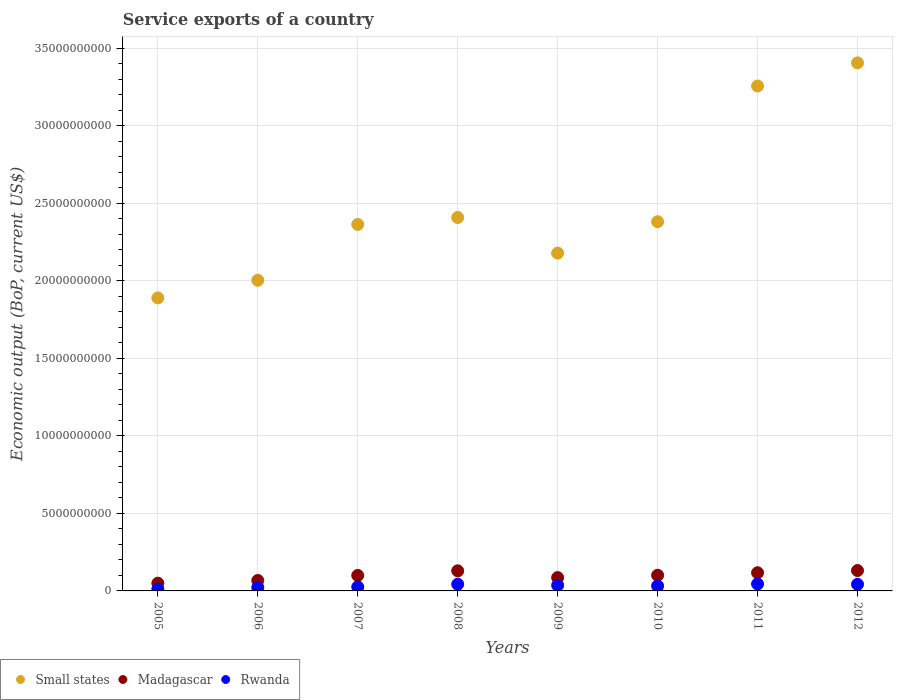What is the service exports in Madagascar in 2009?
Give a very brief answer. 8.60e+08. Across all years, what is the maximum service exports in Rwanda?
Make the answer very short. 4.49e+08. Across all years, what is the minimum service exports in Small states?
Your response must be concise. 1.89e+1. In which year was the service exports in Small states maximum?
Offer a terse response. 2012. In which year was the service exports in Rwanda minimum?
Your answer should be very brief. 2005. What is the total service exports in Madagascar in the graph?
Give a very brief answer. 7.83e+09. What is the difference between the service exports in Madagascar in 2006 and that in 2008?
Your answer should be very brief. -6.23e+08. What is the difference between the service exports in Madagascar in 2009 and the service exports in Rwanda in 2008?
Provide a short and direct response. 4.27e+08. What is the average service exports in Rwanda per year?
Make the answer very short. 3.25e+08. In the year 2011, what is the difference between the service exports in Small states and service exports in Madagascar?
Your answer should be very brief. 3.14e+1. What is the ratio of the service exports in Rwanda in 2005 to that in 2012?
Your answer should be compact. 0.28. Is the service exports in Rwanda in 2006 less than that in 2008?
Your response must be concise. Yes. Is the difference between the service exports in Small states in 2005 and 2012 greater than the difference between the service exports in Madagascar in 2005 and 2012?
Offer a terse response. No. What is the difference between the highest and the second highest service exports in Madagascar?
Offer a terse response. 1.82e+07. What is the difference between the highest and the lowest service exports in Small states?
Keep it short and to the point. 1.52e+1. Is the service exports in Small states strictly greater than the service exports in Rwanda over the years?
Your answer should be very brief. Yes. Is the service exports in Small states strictly less than the service exports in Madagascar over the years?
Give a very brief answer. No. How many dotlines are there?
Your answer should be very brief. 3. How many years are there in the graph?
Offer a very short reply. 8. What is the difference between two consecutive major ticks on the Y-axis?
Make the answer very short. 5.00e+09. Does the graph contain any zero values?
Offer a very short reply. No. Does the graph contain grids?
Keep it short and to the point. Yes. How many legend labels are there?
Offer a very short reply. 3. What is the title of the graph?
Make the answer very short. Service exports of a country. What is the label or title of the Y-axis?
Offer a very short reply. Economic output (BoP, current US$). What is the Economic output (BoP, current US$) of Small states in 2005?
Your response must be concise. 1.89e+1. What is the Economic output (BoP, current US$) of Madagascar in 2005?
Ensure brevity in your answer.  4.99e+08. What is the Economic output (BoP, current US$) in Rwanda in 2005?
Your answer should be very brief. 1.20e+08. What is the Economic output (BoP, current US$) of Small states in 2006?
Your answer should be very brief. 2.00e+1. What is the Economic output (BoP, current US$) in Madagascar in 2006?
Offer a terse response. 6.73e+08. What is the Economic output (BoP, current US$) of Rwanda in 2006?
Your answer should be very brief. 2.24e+08. What is the Economic output (BoP, current US$) of Small states in 2007?
Your response must be concise. 2.36e+1. What is the Economic output (BoP, current US$) in Madagascar in 2007?
Keep it short and to the point. 9.99e+08. What is the Economic output (BoP, current US$) of Rwanda in 2007?
Give a very brief answer. 2.62e+08. What is the Economic output (BoP, current US$) in Small states in 2008?
Provide a succinct answer. 2.41e+1. What is the Economic output (BoP, current US$) in Madagascar in 2008?
Ensure brevity in your answer.  1.30e+09. What is the Economic output (BoP, current US$) of Rwanda in 2008?
Your response must be concise. 4.33e+08. What is the Economic output (BoP, current US$) of Small states in 2009?
Give a very brief answer. 2.18e+1. What is the Economic output (BoP, current US$) of Madagascar in 2009?
Make the answer very short. 8.60e+08. What is the Economic output (BoP, current US$) of Rwanda in 2009?
Provide a succinct answer. 3.61e+08. What is the Economic output (BoP, current US$) in Small states in 2010?
Provide a succinct answer. 2.38e+1. What is the Economic output (BoP, current US$) in Madagascar in 2010?
Your answer should be compact. 1.01e+09. What is the Economic output (BoP, current US$) of Rwanda in 2010?
Provide a short and direct response. 3.25e+08. What is the Economic output (BoP, current US$) of Small states in 2011?
Offer a terse response. 3.26e+1. What is the Economic output (BoP, current US$) of Madagascar in 2011?
Keep it short and to the point. 1.17e+09. What is the Economic output (BoP, current US$) of Rwanda in 2011?
Give a very brief answer. 4.49e+08. What is the Economic output (BoP, current US$) of Small states in 2012?
Your response must be concise. 3.41e+1. What is the Economic output (BoP, current US$) in Madagascar in 2012?
Your answer should be compact. 1.31e+09. What is the Economic output (BoP, current US$) of Rwanda in 2012?
Make the answer very short. 4.25e+08. Across all years, what is the maximum Economic output (BoP, current US$) in Small states?
Give a very brief answer. 3.41e+1. Across all years, what is the maximum Economic output (BoP, current US$) of Madagascar?
Your answer should be compact. 1.31e+09. Across all years, what is the maximum Economic output (BoP, current US$) in Rwanda?
Provide a short and direct response. 4.49e+08. Across all years, what is the minimum Economic output (BoP, current US$) of Small states?
Your answer should be compact. 1.89e+1. Across all years, what is the minimum Economic output (BoP, current US$) in Madagascar?
Keep it short and to the point. 4.99e+08. Across all years, what is the minimum Economic output (BoP, current US$) in Rwanda?
Give a very brief answer. 1.20e+08. What is the total Economic output (BoP, current US$) in Small states in the graph?
Give a very brief answer. 1.99e+11. What is the total Economic output (BoP, current US$) of Madagascar in the graph?
Offer a terse response. 7.83e+09. What is the total Economic output (BoP, current US$) in Rwanda in the graph?
Ensure brevity in your answer.  2.60e+09. What is the difference between the Economic output (BoP, current US$) in Small states in 2005 and that in 2006?
Keep it short and to the point. -1.14e+09. What is the difference between the Economic output (BoP, current US$) of Madagascar in 2005 and that in 2006?
Your answer should be very brief. -1.74e+08. What is the difference between the Economic output (BoP, current US$) of Rwanda in 2005 and that in 2006?
Provide a short and direct response. -1.04e+08. What is the difference between the Economic output (BoP, current US$) of Small states in 2005 and that in 2007?
Your response must be concise. -4.74e+09. What is the difference between the Economic output (BoP, current US$) of Madagascar in 2005 and that in 2007?
Offer a very short reply. -5.00e+08. What is the difference between the Economic output (BoP, current US$) of Rwanda in 2005 and that in 2007?
Give a very brief answer. -1.42e+08. What is the difference between the Economic output (BoP, current US$) of Small states in 2005 and that in 2008?
Ensure brevity in your answer.  -5.19e+09. What is the difference between the Economic output (BoP, current US$) of Madagascar in 2005 and that in 2008?
Offer a very short reply. -7.97e+08. What is the difference between the Economic output (BoP, current US$) in Rwanda in 2005 and that in 2008?
Your answer should be compact. -3.13e+08. What is the difference between the Economic output (BoP, current US$) of Small states in 2005 and that in 2009?
Give a very brief answer. -2.89e+09. What is the difference between the Economic output (BoP, current US$) of Madagascar in 2005 and that in 2009?
Make the answer very short. -3.60e+08. What is the difference between the Economic output (BoP, current US$) in Rwanda in 2005 and that in 2009?
Keep it short and to the point. -2.42e+08. What is the difference between the Economic output (BoP, current US$) of Small states in 2005 and that in 2010?
Offer a very short reply. -4.91e+09. What is the difference between the Economic output (BoP, current US$) of Madagascar in 2005 and that in 2010?
Your answer should be compact. -5.13e+08. What is the difference between the Economic output (BoP, current US$) of Rwanda in 2005 and that in 2010?
Make the answer very short. -2.05e+08. What is the difference between the Economic output (BoP, current US$) of Small states in 2005 and that in 2011?
Ensure brevity in your answer.  -1.37e+1. What is the difference between the Economic output (BoP, current US$) of Madagascar in 2005 and that in 2011?
Offer a very short reply. -6.74e+08. What is the difference between the Economic output (BoP, current US$) in Rwanda in 2005 and that in 2011?
Provide a succinct answer. -3.29e+08. What is the difference between the Economic output (BoP, current US$) in Small states in 2005 and that in 2012?
Offer a terse response. -1.52e+1. What is the difference between the Economic output (BoP, current US$) of Madagascar in 2005 and that in 2012?
Give a very brief answer. -8.15e+08. What is the difference between the Economic output (BoP, current US$) of Rwanda in 2005 and that in 2012?
Keep it short and to the point. -3.06e+08. What is the difference between the Economic output (BoP, current US$) of Small states in 2006 and that in 2007?
Offer a terse response. -3.60e+09. What is the difference between the Economic output (BoP, current US$) of Madagascar in 2006 and that in 2007?
Ensure brevity in your answer.  -3.26e+08. What is the difference between the Economic output (BoP, current US$) in Rwanda in 2006 and that in 2007?
Your response must be concise. -3.82e+07. What is the difference between the Economic output (BoP, current US$) in Small states in 2006 and that in 2008?
Provide a short and direct response. -4.05e+09. What is the difference between the Economic output (BoP, current US$) in Madagascar in 2006 and that in 2008?
Provide a succinct answer. -6.23e+08. What is the difference between the Economic output (BoP, current US$) of Rwanda in 2006 and that in 2008?
Offer a very short reply. -2.09e+08. What is the difference between the Economic output (BoP, current US$) of Small states in 2006 and that in 2009?
Your response must be concise. -1.75e+09. What is the difference between the Economic output (BoP, current US$) in Madagascar in 2006 and that in 2009?
Ensure brevity in your answer.  -1.87e+08. What is the difference between the Economic output (BoP, current US$) of Rwanda in 2006 and that in 2009?
Make the answer very short. -1.38e+08. What is the difference between the Economic output (BoP, current US$) of Small states in 2006 and that in 2010?
Your response must be concise. -3.78e+09. What is the difference between the Economic output (BoP, current US$) of Madagascar in 2006 and that in 2010?
Offer a terse response. -3.39e+08. What is the difference between the Economic output (BoP, current US$) in Rwanda in 2006 and that in 2010?
Give a very brief answer. -1.02e+08. What is the difference between the Economic output (BoP, current US$) in Small states in 2006 and that in 2011?
Ensure brevity in your answer.  -1.25e+1. What is the difference between the Economic output (BoP, current US$) in Madagascar in 2006 and that in 2011?
Your response must be concise. -5.00e+08. What is the difference between the Economic output (BoP, current US$) of Rwanda in 2006 and that in 2011?
Your response must be concise. -2.25e+08. What is the difference between the Economic output (BoP, current US$) in Small states in 2006 and that in 2012?
Keep it short and to the point. -1.40e+1. What is the difference between the Economic output (BoP, current US$) in Madagascar in 2006 and that in 2012?
Provide a short and direct response. -6.42e+08. What is the difference between the Economic output (BoP, current US$) of Rwanda in 2006 and that in 2012?
Your answer should be compact. -2.02e+08. What is the difference between the Economic output (BoP, current US$) in Small states in 2007 and that in 2008?
Provide a short and direct response. -4.49e+08. What is the difference between the Economic output (BoP, current US$) in Madagascar in 2007 and that in 2008?
Your response must be concise. -2.97e+08. What is the difference between the Economic output (BoP, current US$) in Rwanda in 2007 and that in 2008?
Offer a terse response. -1.71e+08. What is the difference between the Economic output (BoP, current US$) in Small states in 2007 and that in 2009?
Offer a terse response. 1.85e+09. What is the difference between the Economic output (BoP, current US$) of Madagascar in 2007 and that in 2009?
Ensure brevity in your answer.  1.40e+08. What is the difference between the Economic output (BoP, current US$) of Rwanda in 2007 and that in 2009?
Ensure brevity in your answer.  -9.95e+07. What is the difference between the Economic output (BoP, current US$) in Small states in 2007 and that in 2010?
Offer a very short reply. -1.75e+08. What is the difference between the Economic output (BoP, current US$) in Madagascar in 2007 and that in 2010?
Your answer should be compact. -1.25e+07. What is the difference between the Economic output (BoP, current US$) in Rwanda in 2007 and that in 2010?
Keep it short and to the point. -6.33e+07. What is the difference between the Economic output (BoP, current US$) in Small states in 2007 and that in 2011?
Keep it short and to the point. -8.93e+09. What is the difference between the Economic output (BoP, current US$) in Madagascar in 2007 and that in 2011?
Keep it short and to the point. -1.74e+08. What is the difference between the Economic output (BoP, current US$) of Rwanda in 2007 and that in 2011?
Make the answer very short. -1.87e+08. What is the difference between the Economic output (BoP, current US$) of Small states in 2007 and that in 2012?
Give a very brief answer. -1.04e+1. What is the difference between the Economic output (BoP, current US$) of Madagascar in 2007 and that in 2012?
Your response must be concise. -3.15e+08. What is the difference between the Economic output (BoP, current US$) of Rwanda in 2007 and that in 2012?
Provide a short and direct response. -1.63e+08. What is the difference between the Economic output (BoP, current US$) in Small states in 2008 and that in 2009?
Your answer should be compact. 2.30e+09. What is the difference between the Economic output (BoP, current US$) in Madagascar in 2008 and that in 2009?
Give a very brief answer. 4.37e+08. What is the difference between the Economic output (BoP, current US$) of Rwanda in 2008 and that in 2009?
Your response must be concise. 7.11e+07. What is the difference between the Economic output (BoP, current US$) of Small states in 2008 and that in 2010?
Offer a very short reply. 2.74e+08. What is the difference between the Economic output (BoP, current US$) in Madagascar in 2008 and that in 2010?
Offer a very short reply. 2.85e+08. What is the difference between the Economic output (BoP, current US$) of Rwanda in 2008 and that in 2010?
Your answer should be very brief. 1.07e+08. What is the difference between the Economic output (BoP, current US$) of Small states in 2008 and that in 2011?
Offer a terse response. -8.48e+09. What is the difference between the Economic output (BoP, current US$) of Madagascar in 2008 and that in 2011?
Your response must be concise. 1.23e+08. What is the difference between the Economic output (BoP, current US$) of Rwanda in 2008 and that in 2011?
Your answer should be compact. -1.59e+07. What is the difference between the Economic output (BoP, current US$) of Small states in 2008 and that in 2012?
Provide a short and direct response. -9.97e+09. What is the difference between the Economic output (BoP, current US$) in Madagascar in 2008 and that in 2012?
Keep it short and to the point. -1.82e+07. What is the difference between the Economic output (BoP, current US$) of Rwanda in 2008 and that in 2012?
Offer a terse response. 7.26e+06. What is the difference between the Economic output (BoP, current US$) of Small states in 2009 and that in 2010?
Offer a terse response. -2.02e+09. What is the difference between the Economic output (BoP, current US$) in Madagascar in 2009 and that in 2010?
Offer a terse response. -1.52e+08. What is the difference between the Economic output (BoP, current US$) in Rwanda in 2009 and that in 2010?
Ensure brevity in your answer.  3.62e+07. What is the difference between the Economic output (BoP, current US$) in Small states in 2009 and that in 2011?
Keep it short and to the point. -1.08e+1. What is the difference between the Economic output (BoP, current US$) of Madagascar in 2009 and that in 2011?
Your response must be concise. -3.13e+08. What is the difference between the Economic output (BoP, current US$) of Rwanda in 2009 and that in 2011?
Your response must be concise. -8.71e+07. What is the difference between the Economic output (BoP, current US$) in Small states in 2009 and that in 2012?
Keep it short and to the point. -1.23e+1. What is the difference between the Economic output (BoP, current US$) of Madagascar in 2009 and that in 2012?
Your answer should be compact. -4.55e+08. What is the difference between the Economic output (BoP, current US$) of Rwanda in 2009 and that in 2012?
Your response must be concise. -6.39e+07. What is the difference between the Economic output (BoP, current US$) in Small states in 2010 and that in 2011?
Your answer should be compact. -8.76e+09. What is the difference between the Economic output (BoP, current US$) in Madagascar in 2010 and that in 2011?
Make the answer very short. -1.61e+08. What is the difference between the Economic output (BoP, current US$) in Rwanda in 2010 and that in 2011?
Offer a very short reply. -1.23e+08. What is the difference between the Economic output (BoP, current US$) in Small states in 2010 and that in 2012?
Keep it short and to the point. -1.02e+1. What is the difference between the Economic output (BoP, current US$) in Madagascar in 2010 and that in 2012?
Your response must be concise. -3.03e+08. What is the difference between the Economic output (BoP, current US$) in Rwanda in 2010 and that in 2012?
Provide a succinct answer. -1.00e+08. What is the difference between the Economic output (BoP, current US$) of Small states in 2011 and that in 2012?
Keep it short and to the point. -1.49e+09. What is the difference between the Economic output (BoP, current US$) in Madagascar in 2011 and that in 2012?
Offer a very short reply. -1.41e+08. What is the difference between the Economic output (BoP, current US$) in Rwanda in 2011 and that in 2012?
Offer a very short reply. 2.32e+07. What is the difference between the Economic output (BoP, current US$) in Small states in 2005 and the Economic output (BoP, current US$) in Madagascar in 2006?
Make the answer very short. 1.82e+1. What is the difference between the Economic output (BoP, current US$) in Small states in 2005 and the Economic output (BoP, current US$) in Rwanda in 2006?
Your answer should be compact. 1.87e+1. What is the difference between the Economic output (BoP, current US$) in Madagascar in 2005 and the Economic output (BoP, current US$) in Rwanda in 2006?
Offer a very short reply. 2.76e+08. What is the difference between the Economic output (BoP, current US$) of Small states in 2005 and the Economic output (BoP, current US$) of Madagascar in 2007?
Your answer should be very brief. 1.79e+1. What is the difference between the Economic output (BoP, current US$) in Small states in 2005 and the Economic output (BoP, current US$) in Rwanda in 2007?
Provide a short and direct response. 1.86e+1. What is the difference between the Economic output (BoP, current US$) in Madagascar in 2005 and the Economic output (BoP, current US$) in Rwanda in 2007?
Make the answer very short. 2.37e+08. What is the difference between the Economic output (BoP, current US$) in Small states in 2005 and the Economic output (BoP, current US$) in Madagascar in 2008?
Provide a succinct answer. 1.76e+1. What is the difference between the Economic output (BoP, current US$) of Small states in 2005 and the Economic output (BoP, current US$) of Rwanda in 2008?
Your answer should be compact. 1.85e+1. What is the difference between the Economic output (BoP, current US$) of Madagascar in 2005 and the Economic output (BoP, current US$) of Rwanda in 2008?
Your answer should be very brief. 6.67e+07. What is the difference between the Economic output (BoP, current US$) of Small states in 2005 and the Economic output (BoP, current US$) of Madagascar in 2009?
Keep it short and to the point. 1.80e+1. What is the difference between the Economic output (BoP, current US$) of Small states in 2005 and the Economic output (BoP, current US$) of Rwanda in 2009?
Provide a short and direct response. 1.85e+1. What is the difference between the Economic output (BoP, current US$) of Madagascar in 2005 and the Economic output (BoP, current US$) of Rwanda in 2009?
Give a very brief answer. 1.38e+08. What is the difference between the Economic output (BoP, current US$) in Small states in 2005 and the Economic output (BoP, current US$) in Madagascar in 2010?
Provide a short and direct response. 1.79e+1. What is the difference between the Economic output (BoP, current US$) of Small states in 2005 and the Economic output (BoP, current US$) of Rwanda in 2010?
Your answer should be very brief. 1.86e+1. What is the difference between the Economic output (BoP, current US$) in Madagascar in 2005 and the Economic output (BoP, current US$) in Rwanda in 2010?
Keep it short and to the point. 1.74e+08. What is the difference between the Economic output (BoP, current US$) in Small states in 2005 and the Economic output (BoP, current US$) in Madagascar in 2011?
Keep it short and to the point. 1.77e+1. What is the difference between the Economic output (BoP, current US$) of Small states in 2005 and the Economic output (BoP, current US$) of Rwanda in 2011?
Your answer should be very brief. 1.85e+1. What is the difference between the Economic output (BoP, current US$) of Madagascar in 2005 and the Economic output (BoP, current US$) of Rwanda in 2011?
Make the answer very short. 5.07e+07. What is the difference between the Economic output (BoP, current US$) of Small states in 2005 and the Economic output (BoP, current US$) of Madagascar in 2012?
Your answer should be very brief. 1.76e+1. What is the difference between the Economic output (BoP, current US$) in Small states in 2005 and the Economic output (BoP, current US$) in Rwanda in 2012?
Provide a succinct answer. 1.85e+1. What is the difference between the Economic output (BoP, current US$) of Madagascar in 2005 and the Economic output (BoP, current US$) of Rwanda in 2012?
Your answer should be compact. 7.39e+07. What is the difference between the Economic output (BoP, current US$) of Small states in 2006 and the Economic output (BoP, current US$) of Madagascar in 2007?
Ensure brevity in your answer.  1.90e+1. What is the difference between the Economic output (BoP, current US$) of Small states in 2006 and the Economic output (BoP, current US$) of Rwanda in 2007?
Provide a short and direct response. 1.98e+1. What is the difference between the Economic output (BoP, current US$) in Madagascar in 2006 and the Economic output (BoP, current US$) in Rwanda in 2007?
Give a very brief answer. 4.11e+08. What is the difference between the Economic output (BoP, current US$) of Small states in 2006 and the Economic output (BoP, current US$) of Madagascar in 2008?
Offer a terse response. 1.87e+1. What is the difference between the Economic output (BoP, current US$) of Small states in 2006 and the Economic output (BoP, current US$) of Rwanda in 2008?
Make the answer very short. 1.96e+1. What is the difference between the Economic output (BoP, current US$) of Madagascar in 2006 and the Economic output (BoP, current US$) of Rwanda in 2008?
Give a very brief answer. 2.40e+08. What is the difference between the Economic output (BoP, current US$) of Small states in 2006 and the Economic output (BoP, current US$) of Madagascar in 2009?
Make the answer very short. 1.92e+1. What is the difference between the Economic output (BoP, current US$) in Small states in 2006 and the Economic output (BoP, current US$) in Rwanda in 2009?
Your answer should be very brief. 1.97e+1. What is the difference between the Economic output (BoP, current US$) of Madagascar in 2006 and the Economic output (BoP, current US$) of Rwanda in 2009?
Ensure brevity in your answer.  3.11e+08. What is the difference between the Economic output (BoP, current US$) of Small states in 2006 and the Economic output (BoP, current US$) of Madagascar in 2010?
Provide a succinct answer. 1.90e+1. What is the difference between the Economic output (BoP, current US$) of Small states in 2006 and the Economic output (BoP, current US$) of Rwanda in 2010?
Ensure brevity in your answer.  1.97e+1. What is the difference between the Economic output (BoP, current US$) of Madagascar in 2006 and the Economic output (BoP, current US$) of Rwanda in 2010?
Your answer should be compact. 3.48e+08. What is the difference between the Economic output (BoP, current US$) in Small states in 2006 and the Economic output (BoP, current US$) in Madagascar in 2011?
Give a very brief answer. 1.89e+1. What is the difference between the Economic output (BoP, current US$) in Small states in 2006 and the Economic output (BoP, current US$) in Rwanda in 2011?
Your answer should be compact. 1.96e+1. What is the difference between the Economic output (BoP, current US$) of Madagascar in 2006 and the Economic output (BoP, current US$) of Rwanda in 2011?
Keep it short and to the point. 2.24e+08. What is the difference between the Economic output (BoP, current US$) of Small states in 2006 and the Economic output (BoP, current US$) of Madagascar in 2012?
Make the answer very short. 1.87e+1. What is the difference between the Economic output (BoP, current US$) of Small states in 2006 and the Economic output (BoP, current US$) of Rwanda in 2012?
Provide a succinct answer. 1.96e+1. What is the difference between the Economic output (BoP, current US$) of Madagascar in 2006 and the Economic output (BoP, current US$) of Rwanda in 2012?
Your response must be concise. 2.48e+08. What is the difference between the Economic output (BoP, current US$) of Small states in 2007 and the Economic output (BoP, current US$) of Madagascar in 2008?
Your response must be concise. 2.23e+1. What is the difference between the Economic output (BoP, current US$) in Small states in 2007 and the Economic output (BoP, current US$) in Rwanda in 2008?
Make the answer very short. 2.32e+1. What is the difference between the Economic output (BoP, current US$) of Madagascar in 2007 and the Economic output (BoP, current US$) of Rwanda in 2008?
Give a very brief answer. 5.67e+08. What is the difference between the Economic output (BoP, current US$) in Small states in 2007 and the Economic output (BoP, current US$) in Madagascar in 2009?
Keep it short and to the point. 2.28e+1. What is the difference between the Economic output (BoP, current US$) in Small states in 2007 and the Economic output (BoP, current US$) in Rwanda in 2009?
Your answer should be compact. 2.33e+1. What is the difference between the Economic output (BoP, current US$) in Madagascar in 2007 and the Economic output (BoP, current US$) in Rwanda in 2009?
Provide a succinct answer. 6.38e+08. What is the difference between the Economic output (BoP, current US$) of Small states in 2007 and the Economic output (BoP, current US$) of Madagascar in 2010?
Your answer should be very brief. 2.26e+1. What is the difference between the Economic output (BoP, current US$) in Small states in 2007 and the Economic output (BoP, current US$) in Rwanda in 2010?
Give a very brief answer. 2.33e+1. What is the difference between the Economic output (BoP, current US$) in Madagascar in 2007 and the Economic output (BoP, current US$) in Rwanda in 2010?
Your answer should be very brief. 6.74e+08. What is the difference between the Economic output (BoP, current US$) of Small states in 2007 and the Economic output (BoP, current US$) of Madagascar in 2011?
Give a very brief answer. 2.25e+1. What is the difference between the Economic output (BoP, current US$) of Small states in 2007 and the Economic output (BoP, current US$) of Rwanda in 2011?
Your response must be concise. 2.32e+1. What is the difference between the Economic output (BoP, current US$) of Madagascar in 2007 and the Economic output (BoP, current US$) of Rwanda in 2011?
Offer a very short reply. 5.51e+08. What is the difference between the Economic output (BoP, current US$) of Small states in 2007 and the Economic output (BoP, current US$) of Madagascar in 2012?
Keep it short and to the point. 2.23e+1. What is the difference between the Economic output (BoP, current US$) of Small states in 2007 and the Economic output (BoP, current US$) of Rwanda in 2012?
Keep it short and to the point. 2.32e+1. What is the difference between the Economic output (BoP, current US$) in Madagascar in 2007 and the Economic output (BoP, current US$) in Rwanda in 2012?
Make the answer very short. 5.74e+08. What is the difference between the Economic output (BoP, current US$) in Small states in 2008 and the Economic output (BoP, current US$) in Madagascar in 2009?
Provide a succinct answer. 2.32e+1. What is the difference between the Economic output (BoP, current US$) in Small states in 2008 and the Economic output (BoP, current US$) in Rwanda in 2009?
Give a very brief answer. 2.37e+1. What is the difference between the Economic output (BoP, current US$) in Madagascar in 2008 and the Economic output (BoP, current US$) in Rwanda in 2009?
Your answer should be very brief. 9.35e+08. What is the difference between the Economic output (BoP, current US$) of Small states in 2008 and the Economic output (BoP, current US$) of Madagascar in 2010?
Your answer should be compact. 2.31e+1. What is the difference between the Economic output (BoP, current US$) of Small states in 2008 and the Economic output (BoP, current US$) of Rwanda in 2010?
Ensure brevity in your answer.  2.38e+1. What is the difference between the Economic output (BoP, current US$) of Madagascar in 2008 and the Economic output (BoP, current US$) of Rwanda in 2010?
Make the answer very short. 9.71e+08. What is the difference between the Economic output (BoP, current US$) of Small states in 2008 and the Economic output (BoP, current US$) of Madagascar in 2011?
Your answer should be compact. 2.29e+1. What is the difference between the Economic output (BoP, current US$) in Small states in 2008 and the Economic output (BoP, current US$) in Rwanda in 2011?
Offer a very short reply. 2.36e+1. What is the difference between the Economic output (BoP, current US$) of Madagascar in 2008 and the Economic output (BoP, current US$) of Rwanda in 2011?
Your response must be concise. 8.48e+08. What is the difference between the Economic output (BoP, current US$) of Small states in 2008 and the Economic output (BoP, current US$) of Madagascar in 2012?
Give a very brief answer. 2.28e+1. What is the difference between the Economic output (BoP, current US$) of Small states in 2008 and the Economic output (BoP, current US$) of Rwanda in 2012?
Offer a terse response. 2.37e+1. What is the difference between the Economic output (BoP, current US$) of Madagascar in 2008 and the Economic output (BoP, current US$) of Rwanda in 2012?
Your response must be concise. 8.71e+08. What is the difference between the Economic output (BoP, current US$) in Small states in 2009 and the Economic output (BoP, current US$) in Madagascar in 2010?
Your answer should be very brief. 2.08e+1. What is the difference between the Economic output (BoP, current US$) in Small states in 2009 and the Economic output (BoP, current US$) in Rwanda in 2010?
Your answer should be very brief. 2.15e+1. What is the difference between the Economic output (BoP, current US$) of Madagascar in 2009 and the Economic output (BoP, current US$) of Rwanda in 2010?
Make the answer very short. 5.34e+08. What is the difference between the Economic output (BoP, current US$) of Small states in 2009 and the Economic output (BoP, current US$) of Madagascar in 2011?
Offer a terse response. 2.06e+1. What is the difference between the Economic output (BoP, current US$) of Small states in 2009 and the Economic output (BoP, current US$) of Rwanda in 2011?
Provide a succinct answer. 2.13e+1. What is the difference between the Economic output (BoP, current US$) in Madagascar in 2009 and the Economic output (BoP, current US$) in Rwanda in 2011?
Ensure brevity in your answer.  4.11e+08. What is the difference between the Economic output (BoP, current US$) in Small states in 2009 and the Economic output (BoP, current US$) in Madagascar in 2012?
Give a very brief answer. 2.05e+1. What is the difference between the Economic output (BoP, current US$) in Small states in 2009 and the Economic output (BoP, current US$) in Rwanda in 2012?
Keep it short and to the point. 2.14e+1. What is the difference between the Economic output (BoP, current US$) in Madagascar in 2009 and the Economic output (BoP, current US$) in Rwanda in 2012?
Provide a short and direct response. 4.34e+08. What is the difference between the Economic output (BoP, current US$) in Small states in 2010 and the Economic output (BoP, current US$) in Madagascar in 2011?
Offer a very short reply. 2.26e+1. What is the difference between the Economic output (BoP, current US$) in Small states in 2010 and the Economic output (BoP, current US$) in Rwanda in 2011?
Your response must be concise. 2.34e+1. What is the difference between the Economic output (BoP, current US$) in Madagascar in 2010 and the Economic output (BoP, current US$) in Rwanda in 2011?
Your answer should be compact. 5.63e+08. What is the difference between the Economic output (BoP, current US$) in Small states in 2010 and the Economic output (BoP, current US$) in Madagascar in 2012?
Ensure brevity in your answer.  2.25e+1. What is the difference between the Economic output (BoP, current US$) of Small states in 2010 and the Economic output (BoP, current US$) of Rwanda in 2012?
Make the answer very short. 2.34e+1. What is the difference between the Economic output (BoP, current US$) of Madagascar in 2010 and the Economic output (BoP, current US$) of Rwanda in 2012?
Give a very brief answer. 5.86e+08. What is the difference between the Economic output (BoP, current US$) of Small states in 2011 and the Economic output (BoP, current US$) of Madagascar in 2012?
Offer a very short reply. 3.13e+1. What is the difference between the Economic output (BoP, current US$) in Small states in 2011 and the Economic output (BoP, current US$) in Rwanda in 2012?
Give a very brief answer. 3.21e+1. What is the difference between the Economic output (BoP, current US$) in Madagascar in 2011 and the Economic output (BoP, current US$) in Rwanda in 2012?
Offer a terse response. 7.48e+08. What is the average Economic output (BoP, current US$) of Small states per year?
Provide a succinct answer. 2.49e+1. What is the average Economic output (BoP, current US$) in Madagascar per year?
Provide a succinct answer. 9.78e+08. What is the average Economic output (BoP, current US$) in Rwanda per year?
Give a very brief answer. 3.25e+08. In the year 2005, what is the difference between the Economic output (BoP, current US$) of Small states and Economic output (BoP, current US$) of Madagascar?
Your answer should be very brief. 1.84e+1. In the year 2005, what is the difference between the Economic output (BoP, current US$) in Small states and Economic output (BoP, current US$) in Rwanda?
Offer a very short reply. 1.88e+1. In the year 2005, what is the difference between the Economic output (BoP, current US$) of Madagascar and Economic output (BoP, current US$) of Rwanda?
Your answer should be very brief. 3.79e+08. In the year 2006, what is the difference between the Economic output (BoP, current US$) in Small states and Economic output (BoP, current US$) in Madagascar?
Your answer should be compact. 1.94e+1. In the year 2006, what is the difference between the Economic output (BoP, current US$) of Small states and Economic output (BoP, current US$) of Rwanda?
Your response must be concise. 1.98e+1. In the year 2006, what is the difference between the Economic output (BoP, current US$) of Madagascar and Economic output (BoP, current US$) of Rwanda?
Ensure brevity in your answer.  4.49e+08. In the year 2007, what is the difference between the Economic output (BoP, current US$) of Small states and Economic output (BoP, current US$) of Madagascar?
Your answer should be very brief. 2.26e+1. In the year 2007, what is the difference between the Economic output (BoP, current US$) in Small states and Economic output (BoP, current US$) in Rwanda?
Ensure brevity in your answer.  2.34e+1. In the year 2007, what is the difference between the Economic output (BoP, current US$) of Madagascar and Economic output (BoP, current US$) of Rwanda?
Provide a short and direct response. 7.37e+08. In the year 2008, what is the difference between the Economic output (BoP, current US$) of Small states and Economic output (BoP, current US$) of Madagascar?
Give a very brief answer. 2.28e+1. In the year 2008, what is the difference between the Economic output (BoP, current US$) in Small states and Economic output (BoP, current US$) in Rwanda?
Make the answer very short. 2.37e+1. In the year 2008, what is the difference between the Economic output (BoP, current US$) in Madagascar and Economic output (BoP, current US$) in Rwanda?
Ensure brevity in your answer.  8.64e+08. In the year 2009, what is the difference between the Economic output (BoP, current US$) in Small states and Economic output (BoP, current US$) in Madagascar?
Your answer should be very brief. 2.09e+1. In the year 2009, what is the difference between the Economic output (BoP, current US$) of Small states and Economic output (BoP, current US$) of Rwanda?
Your response must be concise. 2.14e+1. In the year 2009, what is the difference between the Economic output (BoP, current US$) of Madagascar and Economic output (BoP, current US$) of Rwanda?
Your response must be concise. 4.98e+08. In the year 2010, what is the difference between the Economic output (BoP, current US$) of Small states and Economic output (BoP, current US$) of Madagascar?
Your answer should be compact. 2.28e+1. In the year 2010, what is the difference between the Economic output (BoP, current US$) of Small states and Economic output (BoP, current US$) of Rwanda?
Offer a terse response. 2.35e+1. In the year 2010, what is the difference between the Economic output (BoP, current US$) of Madagascar and Economic output (BoP, current US$) of Rwanda?
Ensure brevity in your answer.  6.87e+08. In the year 2011, what is the difference between the Economic output (BoP, current US$) of Small states and Economic output (BoP, current US$) of Madagascar?
Offer a terse response. 3.14e+1. In the year 2011, what is the difference between the Economic output (BoP, current US$) of Small states and Economic output (BoP, current US$) of Rwanda?
Give a very brief answer. 3.21e+1. In the year 2011, what is the difference between the Economic output (BoP, current US$) of Madagascar and Economic output (BoP, current US$) of Rwanda?
Give a very brief answer. 7.24e+08. In the year 2012, what is the difference between the Economic output (BoP, current US$) in Small states and Economic output (BoP, current US$) in Madagascar?
Keep it short and to the point. 3.27e+1. In the year 2012, what is the difference between the Economic output (BoP, current US$) in Small states and Economic output (BoP, current US$) in Rwanda?
Your response must be concise. 3.36e+1. In the year 2012, what is the difference between the Economic output (BoP, current US$) of Madagascar and Economic output (BoP, current US$) of Rwanda?
Offer a terse response. 8.89e+08. What is the ratio of the Economic output (BoP, current US$) of Small states in 2005 to that in 2006?
Give a very brief answer. 0.94. What is the ratio of the Economic output (BoP, current US$) of Madagascar in 2005 to that in 2006?
Provide a short and direct response. 0.74. What is the ratio of the Economic output (BoP, current US$) in Rwanda in 2005 to that in 2006?
Ensure brevity in your answer.  0.54. What is the ratio of the Economic output (BoP, current US$) in Small states in 2005 to that in 2007?
Keep it short and to the point. 0.8. What is the ratio of the Economic output (BoP, current US$) of Madagascar in 2005 to that in 2007?
Provide a short and direct response. 0.5. What is the ratio of the Economic output (BoP, current US$) in Rwanda in 2005 to that in 2007?
Provide a succinct answer. 0.46. What is the ratio of the Economic output (BoP, current US$) of Small states in 2005 to that in 2008?
Give a very brief answer. 0.78. What is the ratio of the Economic output (BoP, current US$) in Madagascar in 2005 to that in 2008?
Offer a very short reply. 0.39. What is the ratio of the Economic output (BoP, current US$) in Rwanda in 2005 to that in 2008?
Make the answer very short. 0.28. What is the ratio of the Economic output (BoP, current US$) of Small states in 2005 to that in 2009?
Give a very brief answer. 0.87. What is the ratio of the Economic output (BoP, current US$) of Madagascar in 2005 to that in 2009?
Provide a short and direct response. 0.58. What is the ratio of the Economic output (BoP, current US$) in Rwanda in 2005 to that in 2009?
Provide a short and direct response. 0.33. What is the ratio of the Economic output (BoP, current US$) in Small states in 2005 to that in 2010?
Ensure brevity in your answer.  0.79. What is the ratio of the Economic output (BoP, current US$) of Madagascar in 2005 to that in 2010?
Keep it short and to the point. 0.49. What is the ratio of the Economic output (BoP, current US$) in Rwanda in 2005 to that in 2010?
Provide a succinct answer. 0.37. What is the ratio of the Economic output (BoP, current US$) of Small states in 2005 to that in 2011?
Offer a terse response. 0.58. What is the ratio of the Economic output (BoP, current US$) in Madagascar in 2005 to that in 2011?
Offer a very short reply. 0.43. What is the ratio of the Economic output (BoP, current US$) in Rwanda in 2005 to that in 2011?
Offer a very short reply. 0.27. What is the ratio of the Economic output (BoP, current US$) in Small states in 2005 to that in 2012?
Keep it short and to the point. 0.55. What is the ratio of the Economic output (BoP, current US$) of Madagascar in 2005 to that in 2012?
Offer a terse response. 0.38. What is the ratio of the Economic output (BoP, current US$) in Rwanda in 2005 to that in 2012?
Your answer should be compact. 0.28. What is the ratio of the Economic output (BoP, current US$) in Small states in 2006 to that in 2007?
Your answer should be compact. 0.85. What is the ratio of the Economic output (BoP, current US$) of Madagascar in 2006 to that in 2007?
Make the answer very short. 0.67. What is the ratio of the Economic output (BoP, current US$) of Rwanda in 2006 to that in 2007?
Provide a succinct answer. 0.85. What is the ratio of the Economic output (BoP, current US$) of Small states in 2006 to that in 2008?
Your response must be concise. 0.83. What is the ratio of the Economic output (BoP, current US$) in Madagascar in 2006 to that in 2008?
Provide a short and direct response. 0.52. What is the ratio of the Economic output (BoP, current US$) in Rwanda in 2006 to that in 2008?
Give a very brief answer. 0.52. What is the ratio of the Economic output (BoP, current US$) of Small states in 2006 to that in 2009?
Offer a terse response. 0.92. What is the ratio of the Economic output (BoP, current US$) of Madagascar in 2006 to that in 2009?
Your answer should be very brief. 0.78. What is the ratio of the Economic output (BoP, current US$) of Rwanda in 2006 to that in 2009?
Offer a terse response. 0.62. What is the ratio of the Economic output (BoP, current US$) of Small states in 2006 to that in 2010?
Ensure brevity in your answer.  0.84. What is the ratio of the Economic output (BoP, current US$) in Madagascar in 2006 to that in 2010?
Offer a terse response. 0.67. What is the ratio of the Economic output (BoP, current US$) in Rwanda in 2006 to that in 2010?
Ensure brevity in your answer.  0.69. What is the ratio of the Economic output (BoP, current US$) of Small states in 2006 to that in 2011?
Make the answer very short. 0.62. What is the ratio of the Economic output (BoP, current US$) in Madagascar in 2006 to that in 2011?
Give a very brief answer. 0.57. What is the ratio of the Economic output (BoP, current US$) of Rwanda in 2006 to that in 2011?
Ensure brevity in your answer.  0.5. What is the ratio of the Economic output (BoP, current US$) in Small states in 2006 to that in 2012?
Give a very brief answer. 0.59. What is the ratio of the Economic output (BoP, current US$) in Madagascar in 2006 to that in 2012?
Offer a terse response. 0.51. What is the ratio of the Economic output (BoP, current US$) of Rwanda in 2006 to that in 2012?
Give a very brief answer. 0.53. What is the ratio of the Economic output (BoP, current US$) of Small states in 2007 to that in 2008?
Your response must be concise. 0.98. What is the ratio of the Economic output (BoP, current US$) of Madagascar in 2007 to that in 2008?
Your answer should be compact. 0.77. What is the ratio of the Economic output (BoP, current US$) of Rwanda in 2007 to that in 2008?
Offer a very short reply. 0.61. What is the ratio of the Economic output (BoP, current US$) in Small states in 2007 to that in 2009?
Your answer should be very brief. 1.08. What is the ratio of the Economic output (BoP, current US$) in Madagascar in 2007 to that in 2009?
Keep it short and to the point. 1.16. What is the ratio of the Economic output (BoP, current US$) of Rwanda in 2007 to that in 2009?
Your response must be concise. 0.72. What is the ratio of the Economic output (BoP, current US$) in Small states in 2007 to that in 2010?
Make the answer very short. 0.99. What is the ratio of the Economic output (BoP, current US$) in Madagascar in 2007 to that in 2010?
Provide a short and direct response. 0.99. What is the ratio of the Economic output (BoP, current US$) of Rwanda in 2007 to that in 2010?
Ensure brevity in your answer.  0.81. What is the ratio of the Economic output (BoP, current US$) of Small states in 2007 to that in 2011?
Keep it short and to the point. 0.73. What is the ratio of the Economic output (BoP, current US$) of Madagascar in 2007 to that in 2011?
Make the answer very short. 0.85. What is the ratio of the Economic output (BoP, current US$) of Rwanda in 2007 to that in 2011?
Offer a terse response. 0.58. What is the ratio of the Economic output (BoP, current US$) of Small states in 2007 to that in 2012?
Ensure brevity in your answer.  0.69. What is the ratio of the Economic output (BoP, current US$) in Madagascar in 2007 to that in 2012?
Provide a succinct answer. 0.76. What is the ratio of the Economic output (BoP, current US$) of Rwanda in 2007 to that in 2012?
Your answer should be very brief. 0.62. What is the ratio of the Economic output (BoP, current US$) of Small states in 2008 to that in 2009?
Offer a very short reply. 1.11. What is the ratio of the Economic output (BoP, current US$) in Madagascar in 2008 to that in 2009?
Give a very brief answer. 1.51. What is the ratio of the Economic output (BoP, current US$) in Rwanda in 2008 to that in 2009?
Make the answer very short. 1.2. What is the ratio of the Economic output (BoP, current US$) in Small states in 2008 to that in 2010?
Ensure brevity in your answer.  1.01. What is the ratio of the Economic output (BoP, current US$) of Madagascar in 2008 to that in 2010?
Give a very brief answer. 1.28. What is the ratio of the Economic output (BoP, current US$) in Rwanda in 2008 to that in 2010?
Offer a terse response. 1.33. What is the ratio of the Economic output (BoP, current US$) of Small states in 2008 to that in 2011?
Offer a terse response. 0.74. What is the ratio of the Economic output (BoP, current US$) of Madagascar in 2008 to that in 2011?
Your answer should be very brief. 1.11. What is the ratio of the Economic output (BoP, current US$) of Rwanda in 2008 to that in 2011?
Offer a terse response. 0.96. What is the ratio of the Economic output (BoP, current US$) in Small states in 2008 to that in 2012?
Ensure brevity in your answer.  0.71. What is the ratio of the Economic output (BoP, current US$) in Madagascar in 2008 to that in 2012?
Give a very brief answer. 0.99. What is the ratio of the Economic output (BoP, current US$) in Rwanda in 2008 to that in 2012?
Provide a succinct answer. 1.02. What is the ratio of the Economic output (BoP, current US$) in Small states in 2009 to that in 2010?
Ensure brevity in your answer.  0.92. What is the ratio of the Economic output (BoP, current US$) in Madagascar in 2009 to that in 2010?
Your answer should be very brief. 0.85. What is the ratio of the Economic output (BoP, current US$) of Rwanda in 2009 to that in 2010?
Your response must be concise. 1.11. What is the ratio of the Economic output (BoP, current US$) of Small states in 2009 to that in 2011?
Your response must be concise. 0.67. What is the ratio of the Economic output (BoP, current US$) in Madagascar in 2009 to that in 2011?
Your answer should be compact. 0.73. What is the ratio of the Economic output (BoP, current US$) of Rwanda in 2009 to that in 2011?
Offer a terse response. 0.81. What is the ratio of the Economic output (BoP, current US$) of Small states in 2009 to that in 2012?
Offer a terse response. 0.64. What is the ratio of the Economic output (BoP, current US$) of Madagascar in 2009 to that in 2012?
Offer a terse response. 0.65. What is the ratio of the Economic output (BoP, current US$) in Rwanda in 2009 to that in 2012?
Ensure brevity in your answer.  0.85. What is the ratio of the Economic output (BoP, current US$) in Small states in 2010 to that in 2011?
Your response must be concise. 0.73. What is the ratio of the Economic output (BoP, current US$) of Madagascar in 2010 to that in 2011?
Provide a short and direct response. 0.86. What is the ratio of the Economic output (BoP, current US$) in Rwanda in 2010 to that in 2011?
Keep it short and to the point. 0.73. What is the ratio of the Economic output (BoP, current US$) in Small states in 2010 to that in 2012?
Your answer should be compact. 0.7. What is the ratio of the Economic output (BoP, current US$) in Madagascar in 2010 to that in 2012?
Your response must be concise. 0.77. What is the ratio of the Economic output (BoP, current US$) in Rwanda in 2010 to that in 2012?
Offer a very short reply. 0.76. What is the ratio of the Economic output (BoP, current US$) in Small states in 2011 to that in 2012?
Provide a short and direct response. 0.96. What is the ratio of the Economic output (BoP, current US$) of Madagascar in 2011 to that in 2012?
Ensure brevity in your answer.  0.89. What is the ratio of the Economic output (BoP, current US$) in Rwanda in 2011 to that in 2012?
Keep it short and to the point. 1.05. What is the difference between the highest and the second highest Economic output (BoP, current US$) in Small states?
Give a very brief answer. 1.49e+09. What is the difference between the highest and the second highest Economic output (BoP, current US$) of Madagascar?
Offer a very short reply. 1.82e+07. What is the difference between the highest and the second highest Economic output (BoP, current US$) in Rwanda?
Provide a short and direct response. 1.59e+07. What is the difference between the highest and the lowest Economic output (BoP, current US$) in Small states?
Your answer should be very brief. 1.52e+1. What is the difference between the highest and the lowest Economic output (BoP, current US$) of Madagascar?
Offer a very short reply. 8.15e+08. What is the difference between the highest and the lowest Economic output (BoP, current US$) in Rwanda?
Offer a very short reply. 3.29e+08. 